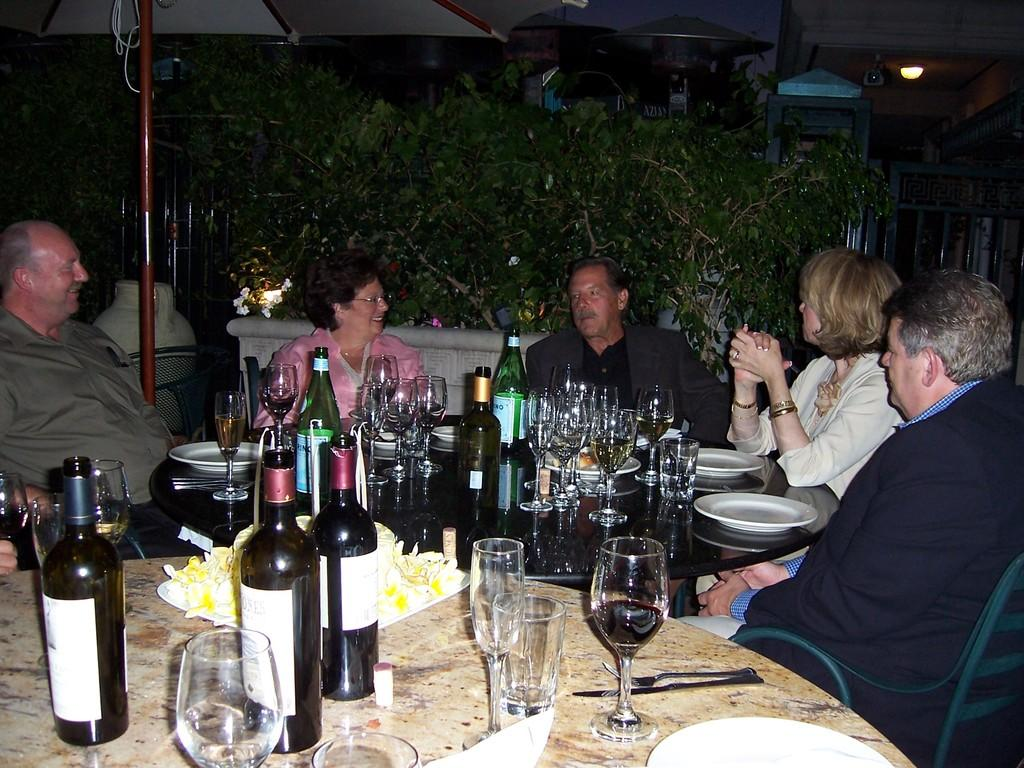What type of vegetation can be seen in the image? There are trees in the image. What are the people in the image doing? The people are sitting on chairs in the image. What is the main piece of furniture in the image? There is a table in the image. What items can be seen on the table? There are bottles, glasses, forks, knives, plates, and tissues on the table. Can you see a crown on the head of any person in the image? There is no crown visible on anyone's head in the image. Are there any frogs present in the image? There are no frogs present in the image. 